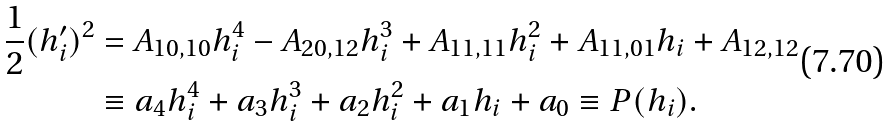<formula> <loc_0><loc_0><loc_500><loc_500>\frac { 1 } { 2 } ( h ^ { \prime } _ { i } ) ^ { 2 } & = A _ { 1 0 , 1 0 } h _ { i } ^ { 4 } - A _ { 2 0 , 1 2 } h _ { i } ^ { 3 } + A _ { 1 1 , 1 1 } h _ { i } ^ { 2 } + A _ { 1 1 , 0 1 } h _ { i } + A _ { 1 2 , 1 2 } \\ & \equiv a _ { 4 } h _ { i } ^ { 4 } + a _ { 3 } h _ { i } ^ { 3 } + a _ { 2 } h _ { i } ^ { 2 } + a _ { 1 } h _ { i } + a _ { 0 } \equiv P ( h _ { i } ) .</formula> 